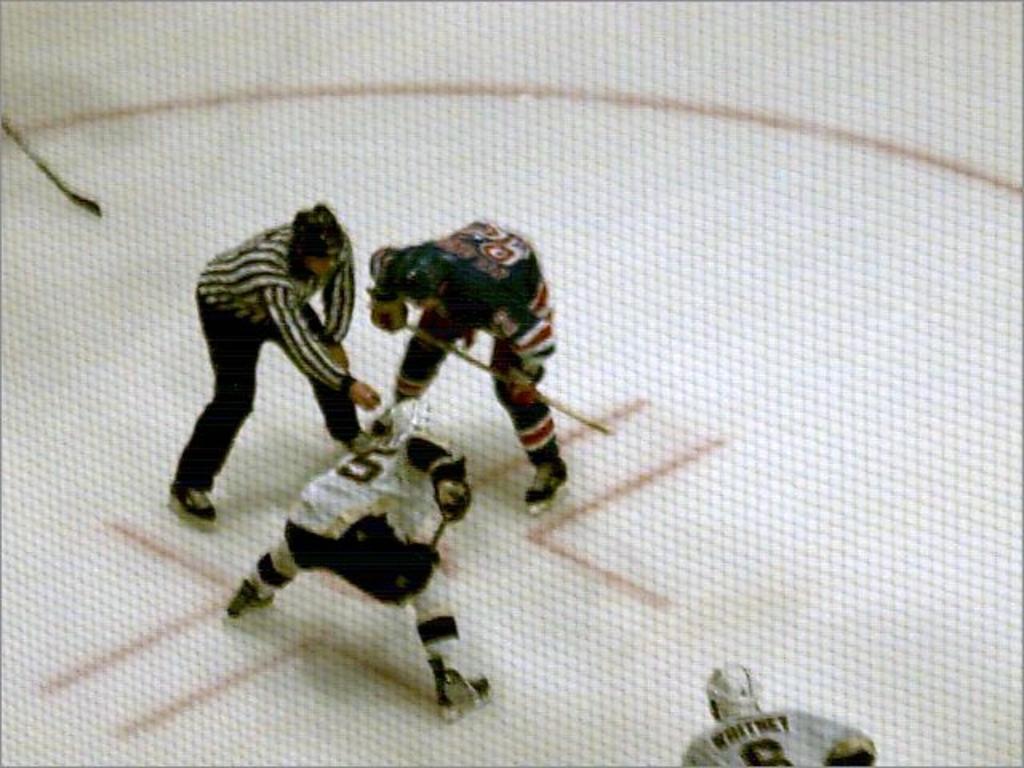Could you give a brief overview of what you see in this image? In this image few persons are standing on the floor. A person is holding a stick. A person wearing a white sports shirt is wearing a helmet. Left top a hockey stick is visible. Bottom of the image there is a person wearing a helmet. 